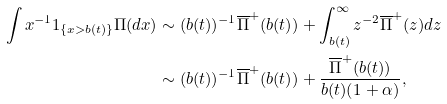<formula> <loc_0><loc_0><loc_500><loc_500>\int x ^ { - 1 } 1 _ { \{ x > b ( t ) \} } \Pi ( d x ) & \sim ( b ( t ) ) ^ { - 1 } \overline { \Pi } ^ { + } ( b ( t ) ) + \int ^ { \infty } _ { b ( t ) } z ^ { - 2 } \overline { \Pi } ^ { + } ( z ) d z \\ & \sim ( b ( t ) ) ^ { - 1 } \overline { \Pi } ^ { + } ( b ( t ) ) + \frac { \overline { \Pi } ^ { + } ( b ( t ) ) } { b ( t ) ( 1 + \alpha ) } ,</formula> 